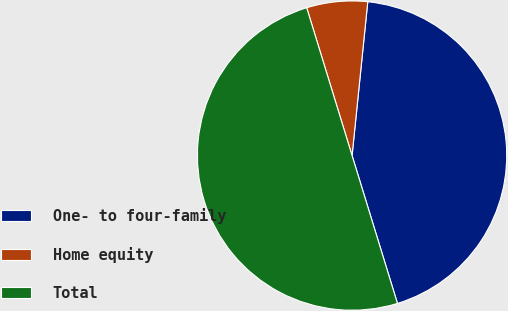Convert chart. <chart><loc_0><loc_0><loc_500><loc_500><pie_chart><fcel>One- to four-family<fcel>Home equity<fcel>Total<nl><fcel>43.64%<fcel>6.36%<fcel>50.0%<nl></chart> 